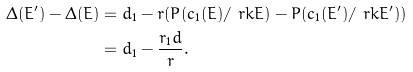<formula> <loc_0><loc_0><loc_500><loc_500>\Delta ( E ^ { \prime } ) - \Delta ( E ) & = d _ { 1 } - r ( P ( c _ { 1 } ( E ) / \ r k E ) - P ( c _ { 1 } ( E ^ { \prime } ) / \ r k E ^ { \prime } ) ) \\ & = d _ { 1 } - \frac { r _ { 1 } d } { r } .</formula> 